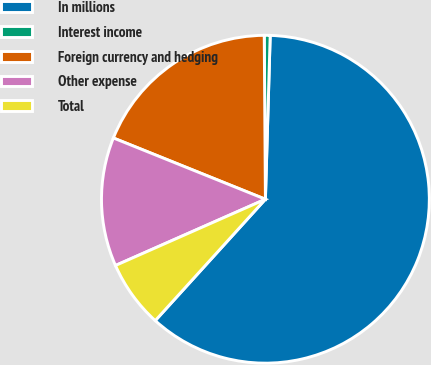Convert chart to OTSL. <chart><loc_0><loc_0><loc_500><loc_500><pie_chart><fcel>In millions<fcel>Interest income<fcel>Foreign currency and hedging<fcel>Other expense<fcel>Total<nl><fcel>61.27%<fcel>0.58%<fcel>18.79%<fcel>12.72%<fcel>6.65%<nl></chart> 